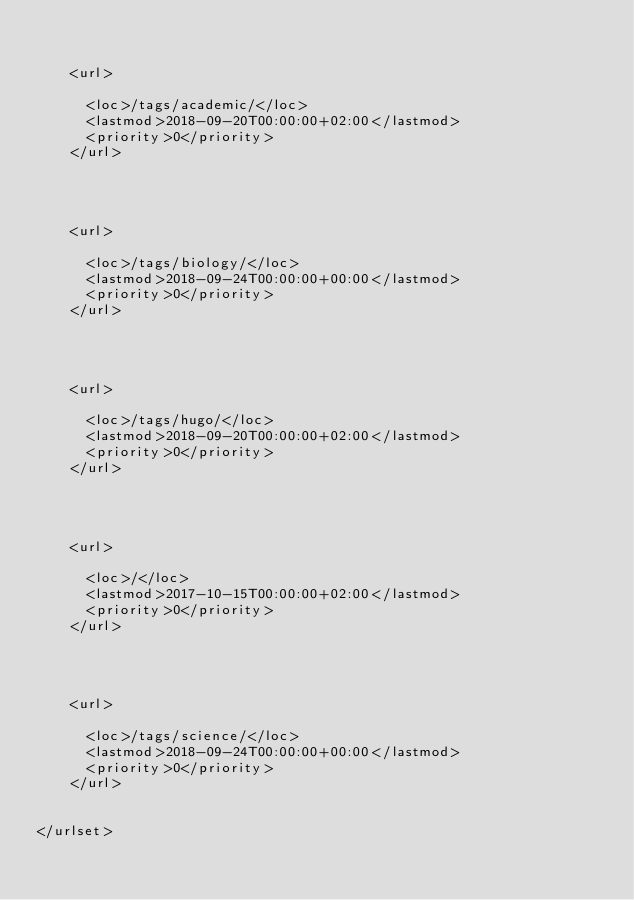<code> <loc_0><loc_0><loc_500><loc_500><_XML_>    
    
    <url>
    
      <loc>/tags/academic/</loc>
      <lastmod>2018-09-20T00:00:00+02:00</lastmod>
      <priority>0</priority>
    </url>
    
  
    
    
    <url>
    
      <loc>/tags/biology/</loc>
      <lastmod>2018-09-24T00:00:00+00:00</lastmod>
      <priority>0</priority>
    </url>
    
  
    
    
    <url>
    
      <loc>/tags/hugo/</loc>
      <lastmod>2018-09-20T00:00:00+02:00</lastmod>
      <priority>0</priority>
    </url>
    
  
    
    
    <url>
    
      <loc>/</loc>
      <lastmod>2017-10-15T00:00:00+02:00</lastmod>
      <priority>0</priority>
    </url>
    
  
    
    
    <url>
    
      <loc>/tags/science/</loc>
      <lastmod>2018-09-24T00:00:00+00:00</lastmod>
      <priority>0</priority>
    </url>
    
  
</urlset>
</code> 